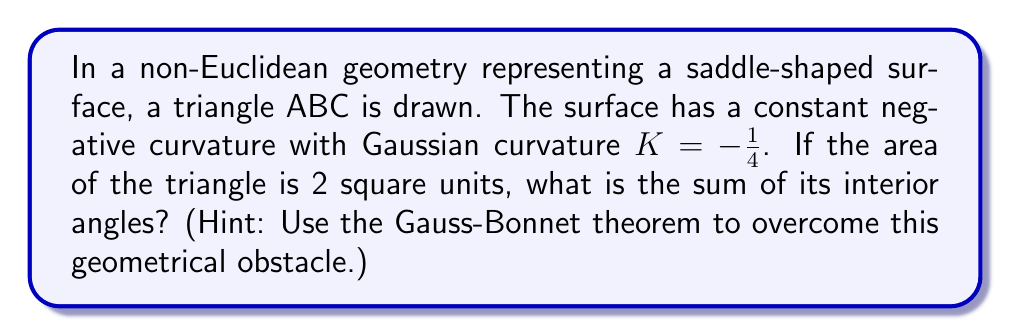Provide a solution to this math problem. Let's approach this step-by-step:

1) The Gauss-Bonnet theorem for a triangle on a surface with Gaussian curvature $K$ states:

   $$\alpha + \beta + \gamma = \pi - KA$$

   where $\alpha$, $\beta$, and $\gamma$ are the interior angles of the triangle, and $A$ is the area of the triangle.

2) We are given:
   - Gaussian curvature $K = -\frac{1}{4}$
   - Area of the triangle $A = 2$ square units

3) Let's substitute these values into the Gauss-Bonnet formula:

   $$\alpha + \beta + \gamma = \pi - \left(-\frac{1}{4}\right)(2)$$

4) Simplify the right side:

   $$\alpha + \beta + \gamma = \pi + \frac{1}{2}$$

5) Convert $\pi$ to radians:

   $$\alpha + \beta + \gamma = 3.14159... + 0.5 = 3.64159...$$

6) This sum is greater than $\pi$ (or 180°), which is characteristic of triangles on surfaces with negative curvature.
Answer: $3.64159...$ radians (or approximately 208.6°) 